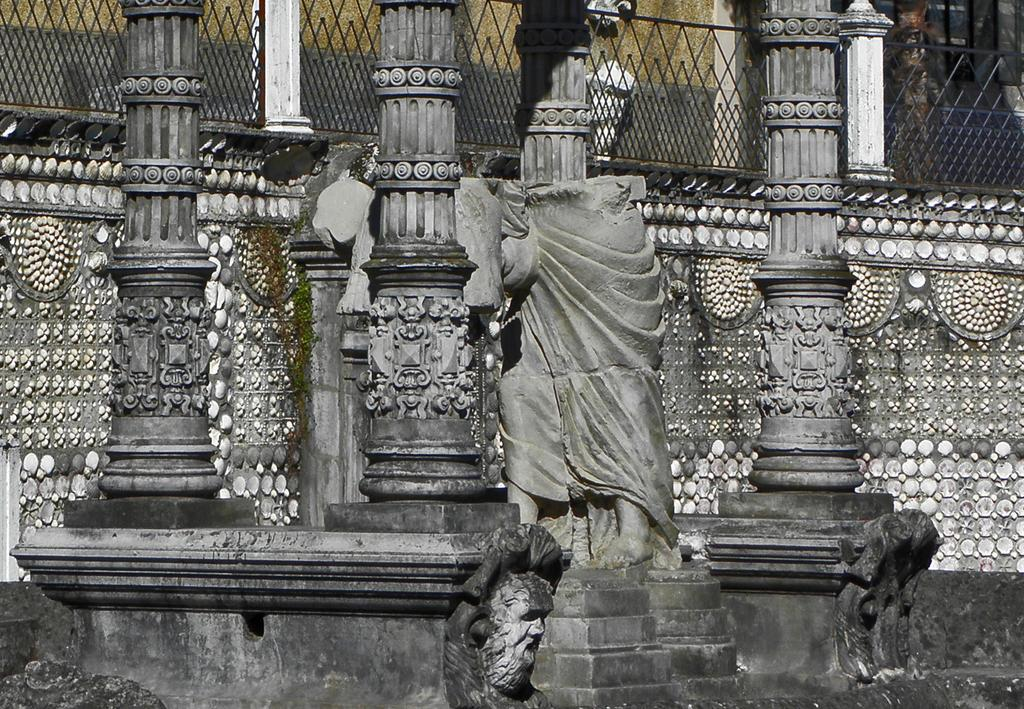What is the main subject in the image? There is a statue in the image. What other architectural features can be seen in the image? There are pillars with sculptures in the image. What type of structure is visible in the image? There is a wall in the image. What can be seen in the background of the image? There is a black color fence in the background of the image. How many trucks are parked near the statue in the image? There are no trucks present in the image. What type of army is depicted in the image? There is no army depicted in the image; it features a statue, pillars with sculptures, a wall, and a black color fence. 